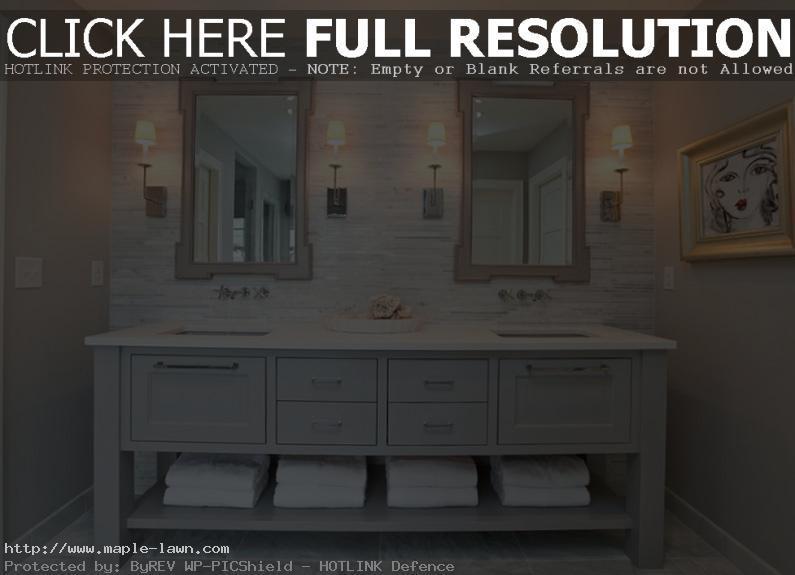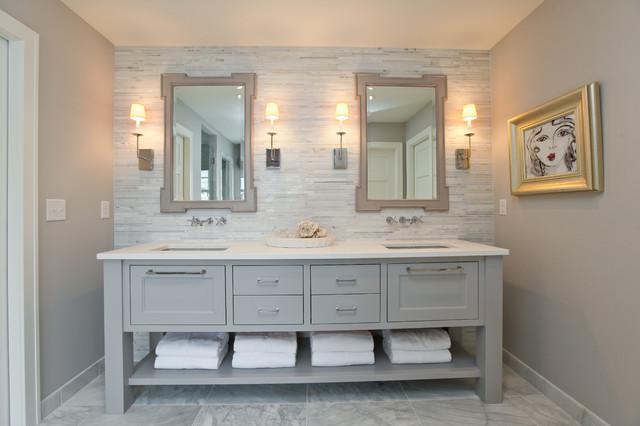The first image is the image on the left, the second image is the image on the right. Assess this claim about the two images: "One of the sink vanities does not have a double mirror above it.". Correct or not? Answer yes or no. No. The first image is the image on the left, the second image is the image on the right. Considering the images on both sides, is "At least one image shows a pair of mirrors over a double vanity with the bottom of its cabinet open and holding towels." valid? Answer yes or no. Yes. 